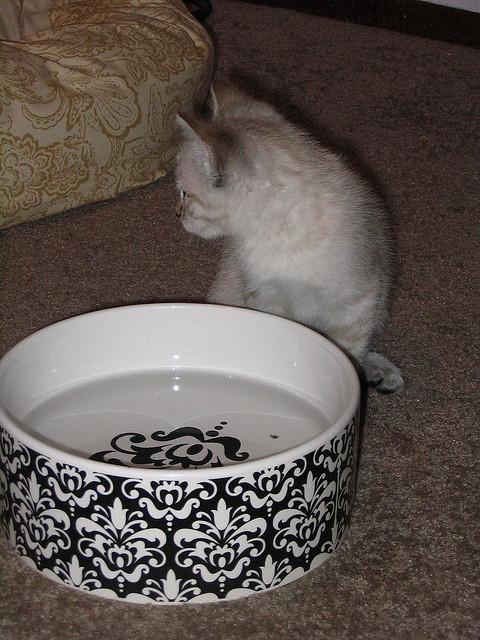Which one of the things that kittens are known for drinking is in the scene?
Quick response, please. Water. What is in the bowl?
Give a very brief answer. Water. Is the kitten looking forward?
Quick response, please. No. 